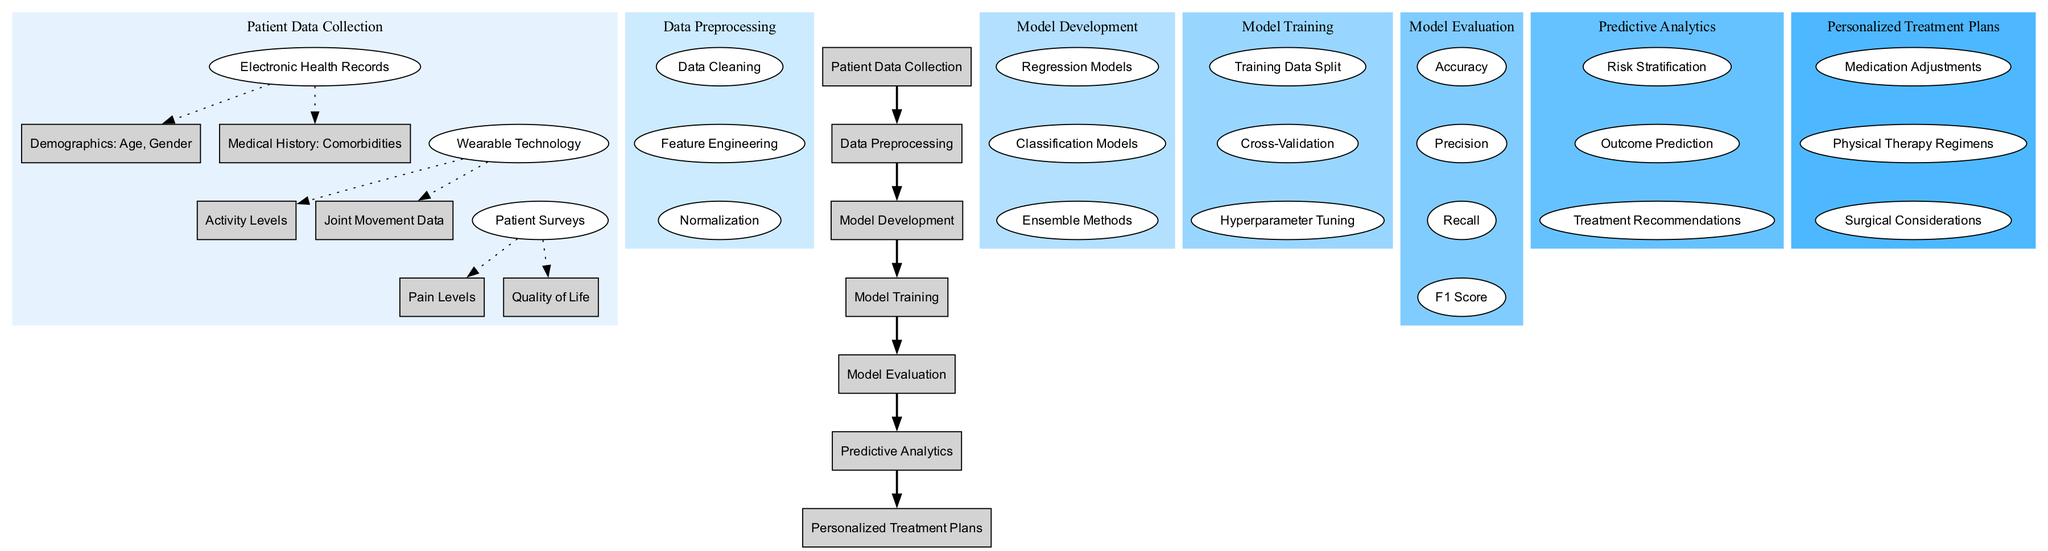What is the first node of the diagram? The first node is "Patient Data Collection," which is the starting point of the entire diagram and represents the initial stage of gathering data.
Answer: Patient Data Collection How many children does "Data Preprocessing" have? "Data Preprocessing" has three children: "Data Cleaning," "Feature Engineering," and "Normalization," indicating the steps taken to prepare data before modeling.
Answer: 3 Name one method used in "Model Development." One of the methods used in "Model Development" is "Regression Models," which is mentioned as a type of approach to develop the predictive models.
Answer: Regression Models What is the purpose of "Predictive Analytics"? The purpose of "Predictive Analytics" includes "Risk Stratification," "Outcome Prediction," and "Treatment Recommendations," which collectively aim to apply data analysis for better treatment plans.
Answer: Risk Stratification, Outcome Prediction, Treatment Recommendations Which node leads to "Medication Adjustments"? The node that leads to "Medication Adjustments" is "Personalized Treatment Plans," which outlines the specific actions to be taken based on predictive analytics results.
Answer: Personalized Treatment Plans What does "Model Evaluation" measure? "Model Evaluation" measures "Accuracy," "Precision," "Recall," and "F1 Score," which are key metrics used to assess the performance of the developed models.
Answer: Accuracy, Precision, Recall, F1 Score How many nodes are under "Wearable Technology"? There are two nodes under "Wearable Technology": "Activity Levels" and "Joint Movement Data," reflecting the types of data collected from patients' wearables.
Answer: 2 What is the relationship between "Model Training" and "Model Evaluation"? The relationship between "Model Training" and "Model Evaluation" is sequential; once the model is trained through methods like "Training Data Split" and "Hyperparameter Tuning," it proceeds to evaluation to test its performance.
Answer: Sequential relationship What type of models are mentioned in "Model Development"? The types of models mentioned in "Model Development" include "Regression Models," "Classification Models," and "Ensemble Methods," highlighting different approaches to predicting outcomes.
Answer: Regression Models, Classification Models, Ensemble Methods 